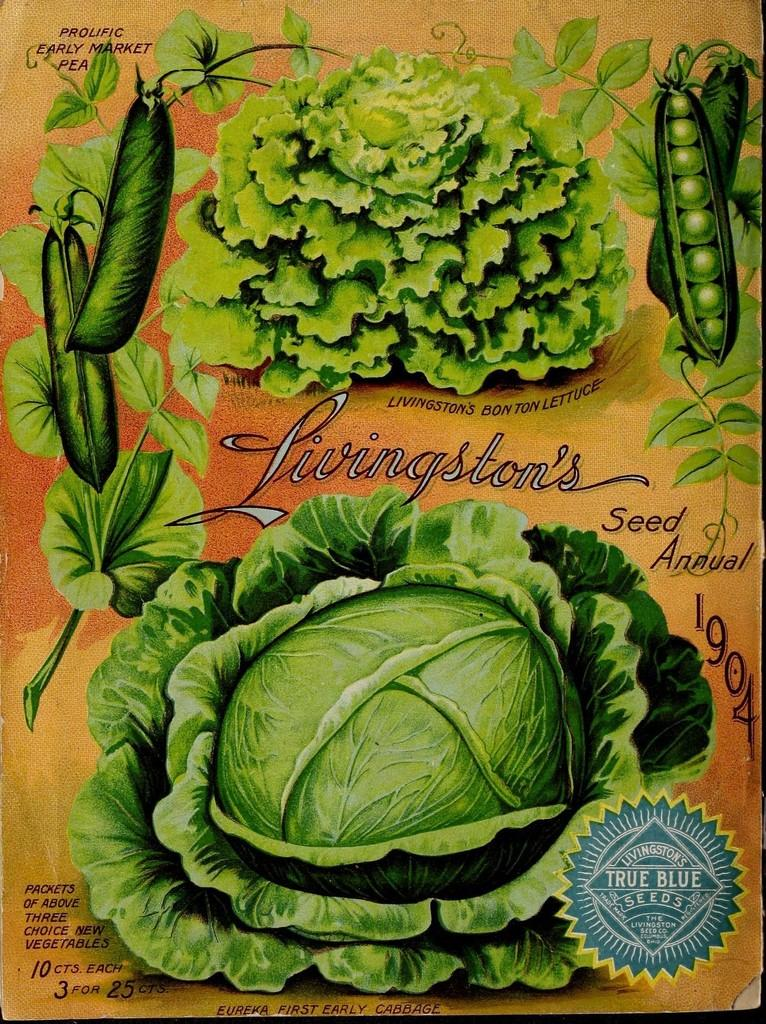What is featured in the image? There is a poster in the image. What type of images are on the poster? The poster contains pictures of vegetables. Is there any text on the poster? Yes, there is text on the poster. What type of protest is taking place in the image? There is no protest present in the image; it only features a poster with pictures of vegetables and text. Can you see any arms in the image? There are no arms visible in the image, as it only contains a poster with pictures of vegetables and text. 